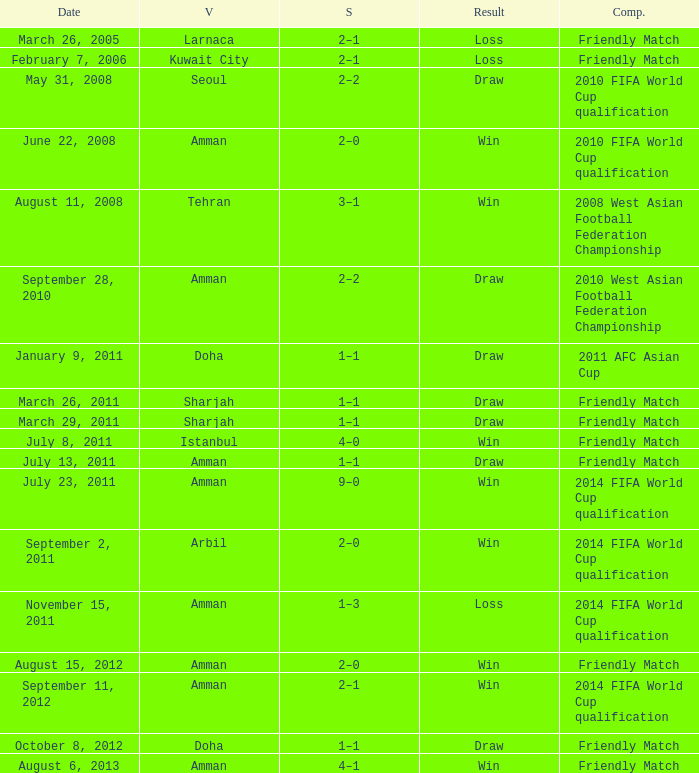WHat was the result of the friendly match that was played on october 8, 2012? Draw. 